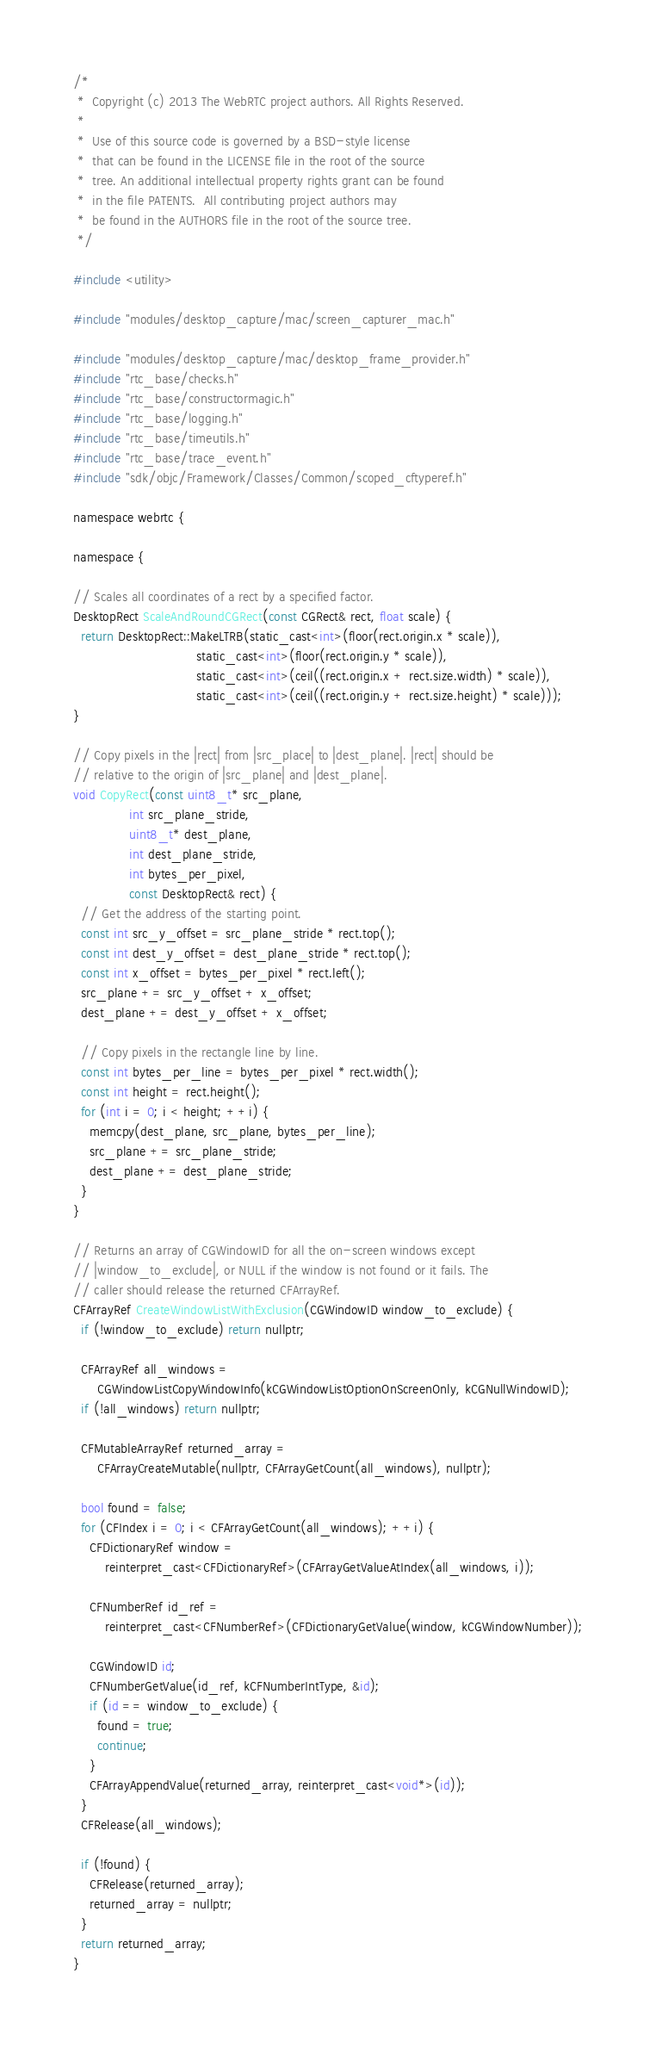Convert code to text. <code><loc_0><loc_0><loc_500><loc_500><_ObjectiveC_>/*
 *  Copyright (c) 2013 The WebRTC project authors. All Rights Reserved.
 *
 *  Use of this source code is governed by a BSD-style license
 *  that can be found in the LICENSE file in the root of the source
 *  tree. An additional intellectual property rights grant can be found
 *  in the file PATENTS.  All contributing project authors may
 *  be found in the AUTHORS file in the root of the source tree.
 */

#include <utility>

#include "modules/desktop_capture/mac/screen_capturer_mac.h"

#include "modules/desktop_capture/mac/desktop_frame_provider.h"
#include "rtc_base/checks.h"
#include "rtc_base/constructormagic.h"
#include "rtc_base/logging.h"
#include "rtc_base/timeutils.h"
#include "rtc_base/trace_event.h"
#include "sdk/objc/Framework/Classes/Common/scoped_cftyperef.h"

namespace webrtc {

namespace {

// Scales all coordinates of a rect by a specified factor.
DesktopRect ScaleAndRoundCGRect(const CGRect& rect, float scale) {
  return DesktopRect::MakeLTRB(static_cast<int>(floor(rect.origin.x * scale)),
                               static_cast<int>(floor(rect.origin.y * scale)),
                               static_cast<int>(ceil((rect.origin.x + rect.size.width) * scale)),
                               static_cast<int>(ceil((rect.origin.y + rect.size.height) * scale)));
}

// Copy pixels in the |rect| from |src_place| to |dest_plane|. |rect| should be
// relative to the origin of |src_plane| and |dest_plane|.
void CopyRect(const uint8_t* src_plane,
              int src_plane_stride,
              uint8_t* dest_plane,
              int dest_plane_stride,
              int bytes_per_pixel,
              const DesktopRect& rect) {
  // Get the address of the starting point.
  const int src_y_offset = src_plane_stride * rect.top();
  const int dest_y_offset = dest_plane_stride * rect.top();
  const int x_offset = bytes_per_pixel * rect.left();
  src_plane += src_y_offset + x_offset;
  dest_plane += dest_y_offset + x_offset;

  // Copy pixels in the rectangle line by line.
  const int bytes_per_line = bytes_per_pixel * rect.width();
  const int height = rect.height();
  for (int i = 0; i < height; ++i) {
    memcpy(dest_plane, src_plane, bytes_per_line);
    src_plane += src_plane_stride;
    dest_plane += dest_plane_stride;
  }
}

// Returns an array of CGWindowID for all the on-screen windows except
// |window_to_exclude|, or NULL if the window is not found or it fails. The
// caller should release the returned CFArrayRef.
CFArrayRef CreateWindowListWithExclusion(CGWindowID window_to_exclude) {
  if (!window_to_exclude) return nullptr;

  CFArrayRef all_windows =
      CGWindowListCopyWindowInfo(kCGWindowListOptionOnScreenOnly, kCGNullWindowID);
  if (!all_windows) return nullptr;

  CFMutableArrayRef returned_array =
      CFArrayCreateMutable(nullptr, CFArrayGetCount(all_windows), nullptr);

  bool found = false;
  for (CFIndex i = 0; i < CFArrayGetCount(all_windows); ++i) {
    CFDictionaryRef window =
        reinterpret_cast<CFDictionaryRef>(CFArrayGetValueAtIndex(all_windows, i));

    CFNumberRef id_ref =
        reinterpret_cast<CFNumberRef>(CFDictionaryGetValue(window, kCGWindowNumber));

    CGWindowID id;
    CFNumberGetValue(id_ref, kCFNumberIntType, &id);
    if (id == window_to_exclude) {
      found = true;
      continue;
    }
    CFArrayAppendValue(returned_array, reinterpret_cast<void*>(id));
  }
  CFRelease(all_windows);

  if (!found) {
    CFRelease(returned_array);
    returned_array = nullptr;
  }
  return returned_array;
}
</code> 